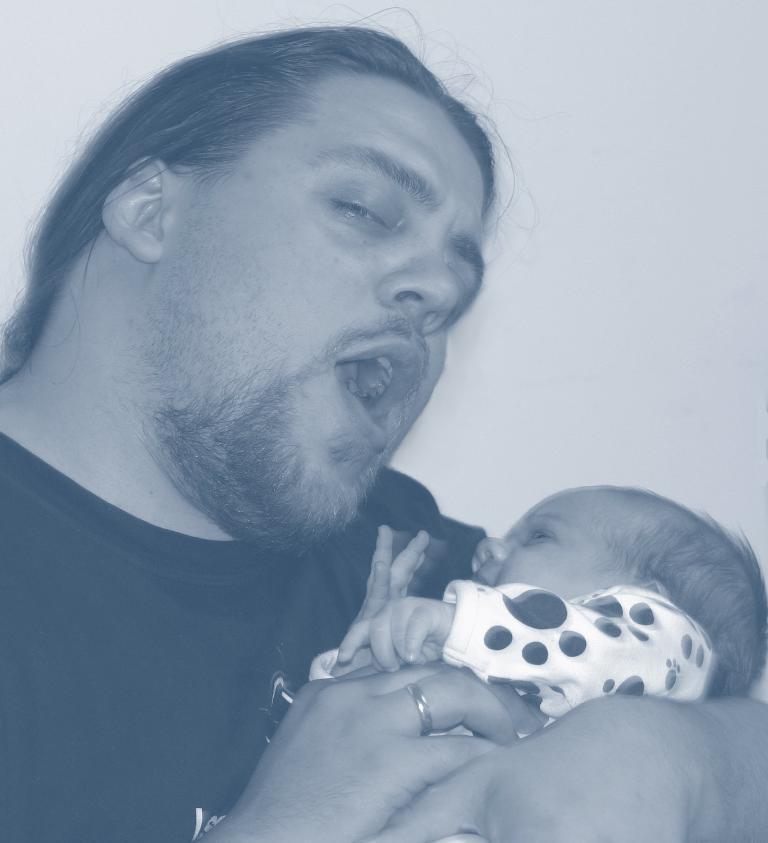Could you give a brief overview of what you see in this image? On the left side, there is a person, speaking and holding a baby with both hands. And the background is white in color. 